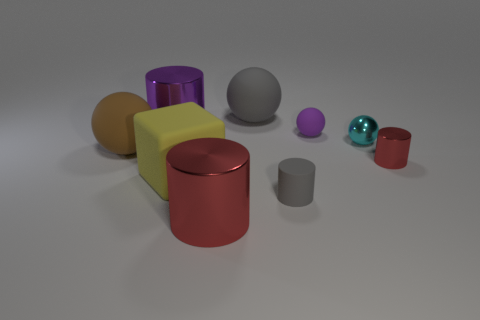Can you describe the texture of the objects? Certainly! The objects in the image have a smooth, matte finish. This is particularly noticeable on the purple cylinder and the teal sphere, which reflect light in a way that suggests a metallic texture. The yellow cube and the orange cylinder appear to have a less reflective surface, indicating a possibly softer or plastic-like material. 